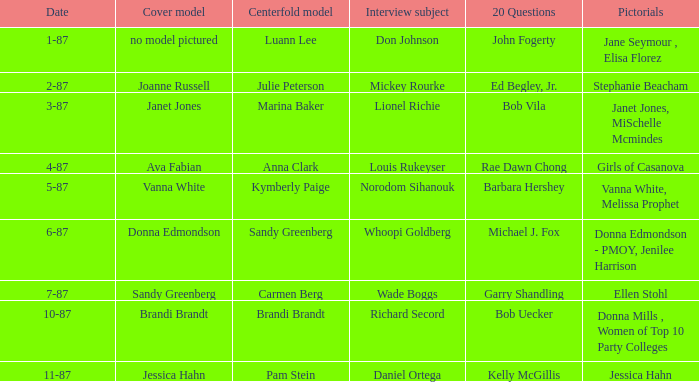When was the Kymberly Paige the Centerfold? 5-87. 